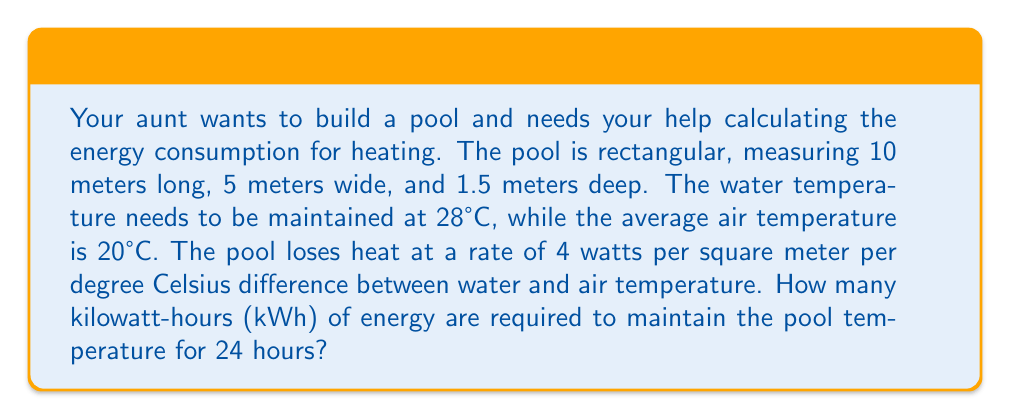What is the answer to this math problem? Let's break this down step-by-step:

1. Calculate the surface area of the pool:
   $$ A = L \times W = 10 \text{ m} \times 5 \text{ m} = 50 \text{ m}^2 $$

2. Calculate the temperature difference:
   $$ \Delta T = T_{\text{water}} - T_{\text{air}} = 28°C - 20°C = 8°C $$

3. Calculate the heat loss rate:
   $$ \text{Heat Loss Rate} = 4 \text{ W}/(\text{m}^2 \cdot °C) \times 50 \text{ m}^2 \times 8°C = 1600 \text{ W} $$

4. Convert watts to kilowatts:
   $$ 1600 \text{ W} = 1.6 \text{ kW} $$

5. Calculate energy consumption for 24 hours:
   $$ \text{Energy} = \text{Power} \times \text{Time} $$
   $$ \text{Energy} = 1.6 \text{ kW} \times 24 \text{ hours} = 38.4 \text{ kWh} $$

Therefore, 38.4 kWh of energy are required to maintain the pool temperature for 24 hours.
Answer: 38.4 kWh 